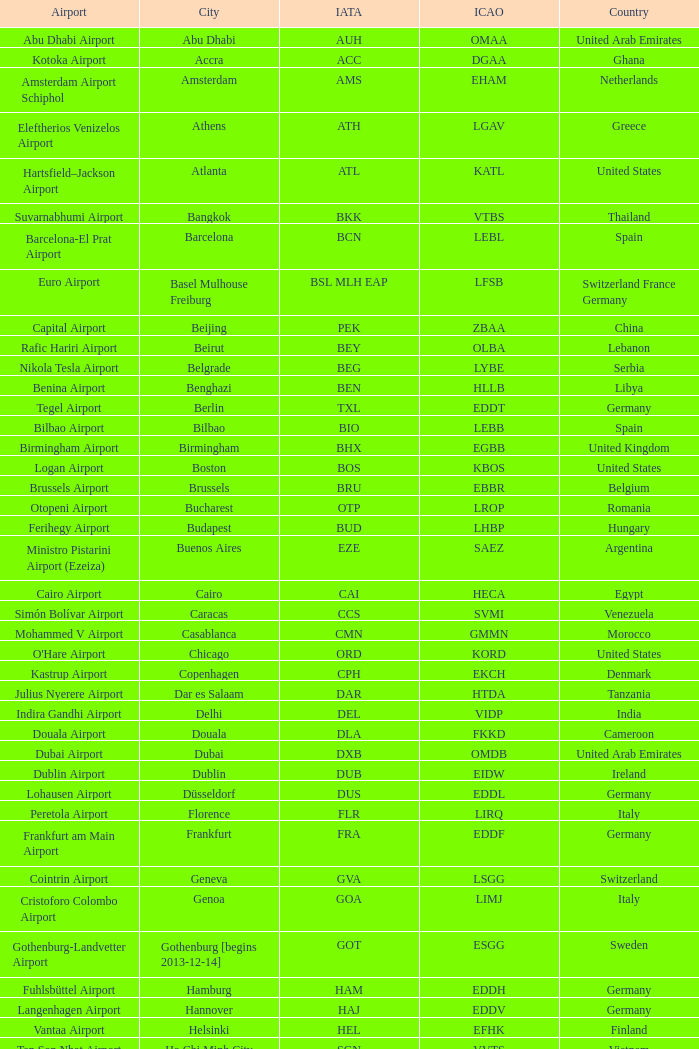What is the IATA for Ringway Airport in the United Kingdom? MAN. 